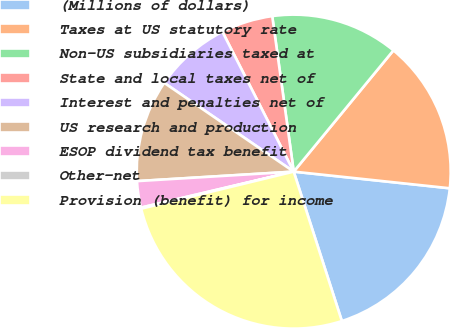<chart> <loc_0><loc_0><loc_500><loc_500><pie_chart><fcel>(Millions of dollars)<fcel>Taxes at US statutory rate<fcel>Non-US subsidiaries taxed at<fcel>State and local taxes net of<fcel>Interest and penalties net of<fcel>US research and production<fcel>ESOP dividend tax benefit<fcel>Other-net<fcel>Provision (benefit) for income<nl><fcel>18.35%<fcel>15.74%<fcel>13.14%<fcel>5.32%<fcel>7.93%<fcel>10.53%<fcel>2.72%<fcel>0.11%<fcel>26.17%<nl></chart> 